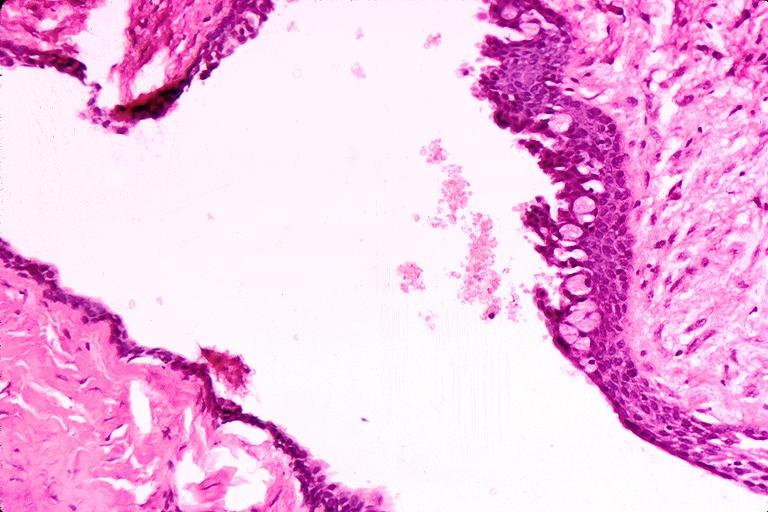does this image show cyst?
Answer the question using a single word or phrase. Yes 